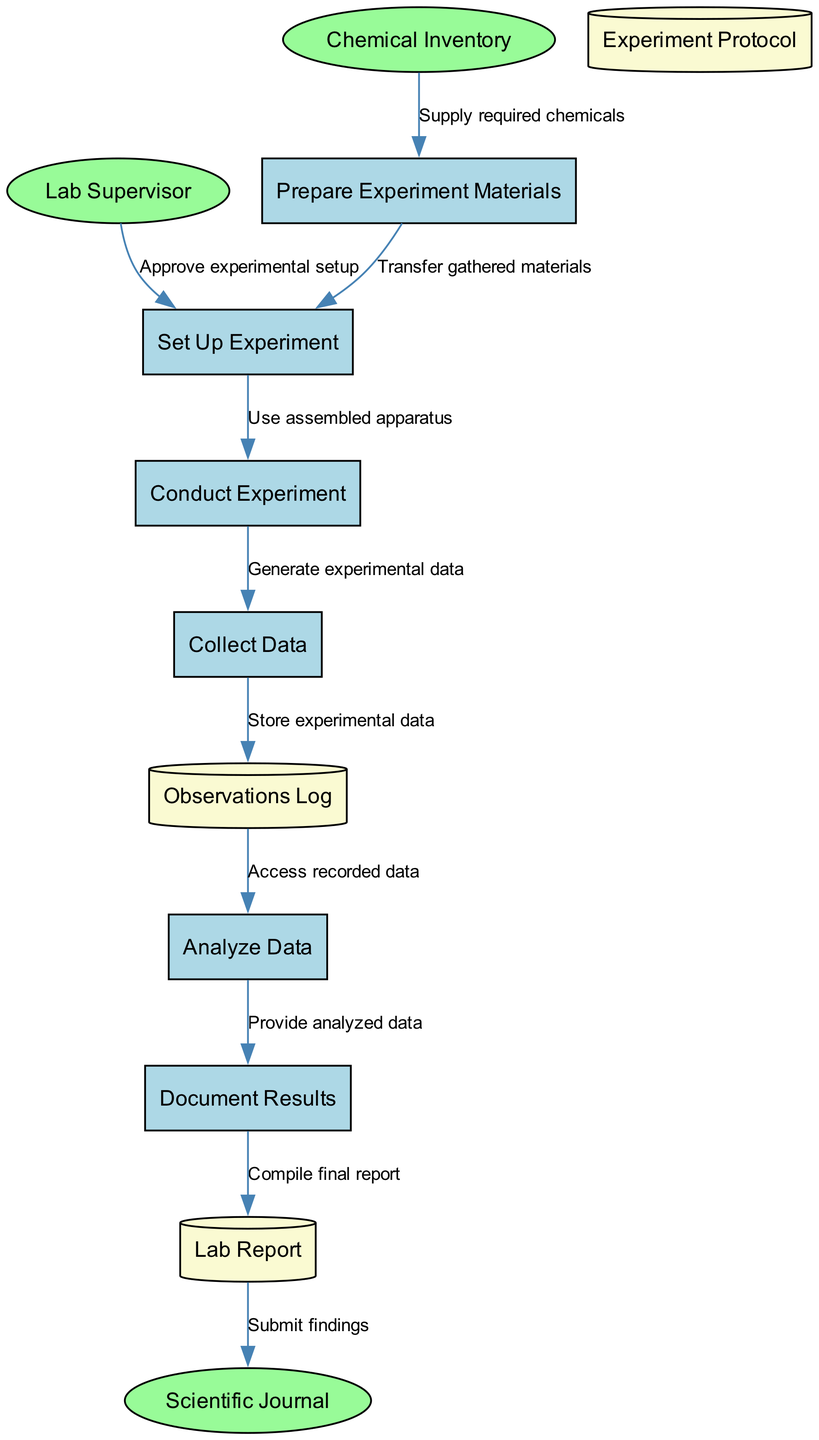What is the first process in the diagram? The first process listed in the diagram is "Prepare Experiment Materials," which is the starting point for conducting a chemical experiment.
Answer: Prepare Experiment Materials How many external entities are present in the diagram? The diagram contains three external entities: "Chemical Inventory," "Lab Supervisor," and "Scientific Journal." Counting them gives a total of three.
Answer: 3 What type of data store is used for recording experimental observations? The data store used for recording experimental observations is called "Observations Log," which specifically logs experimental data collected during the experiment.
Answer: Observations Log Which process receives approval from the Lab Supervisor? The process "Set Up Experiment" is the one that receives approval from the Lab Supervisor, as indicated in the data flow from the Lab Supervisor to the "Set Up Experiment."
Answer: Set Up Experiment What happens after the "Collect Data" process? After the "Collect Data" process, the recorded data is stored in the "Observations Log," which ensures that all experimental observations and measurements are properly logged.
Answer: Observations Log Which external entity is the final destination for the Lab Report? The final destination for the Lab Report is the "Scientific Journal," where the findings from the experiment are submitted for publication.
Answer: Scientific Journal What process follows "Analyze Data"? The process that follows "Analyze Data" is "Document Results," which compiles the analyzed data into a lab report.
Answer: Document Results How many processes are there in total? There are six processes in the diagram: Prepare Experiment Materials, Set Up Experiment, Conduct Experiment, Collect Data, Analyze Data, and Document Results. Counting these gives a total of six.
Answer: 6 What is the relationship between "Conduct Experiment" and "Collect Data"? The "Conduct Experiment" process generates experimental data, which directly flows to the "Collect Data" process, indicating that data collection occurs as the experiment is conducted.
Answer: Generate experimental data 